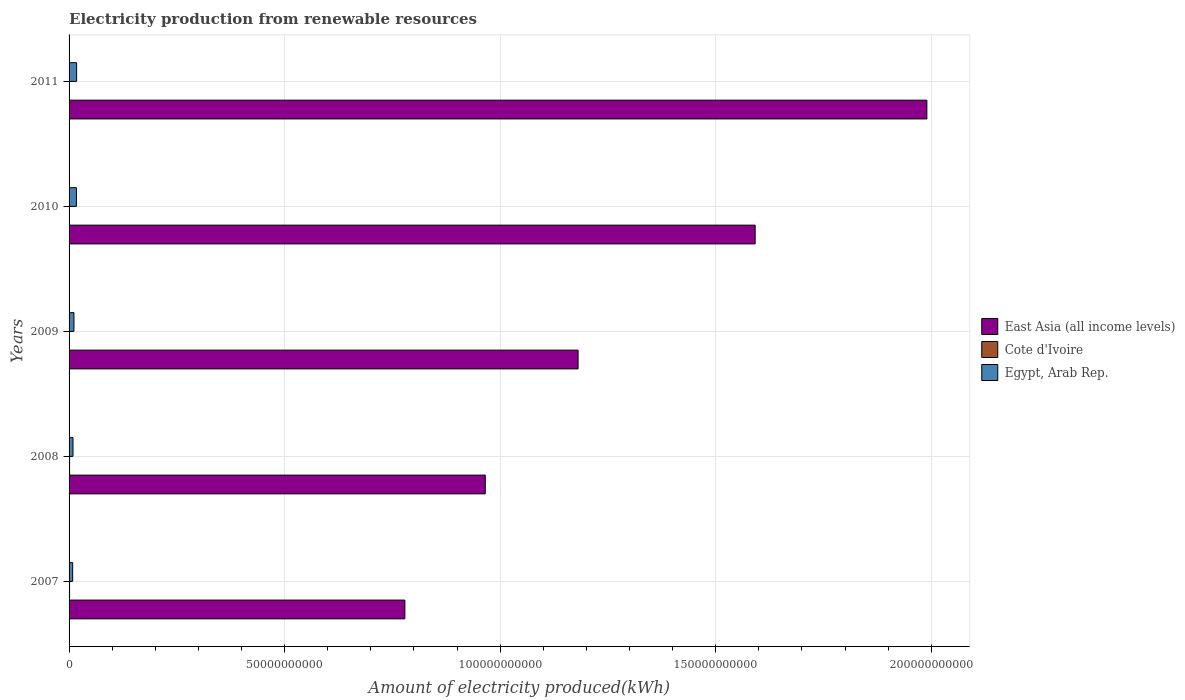How many different coloured bars are there?
Your answer should be very brief. 3. Are the number of bars on each tick of the Y-axis equal?
Provide a succinct answer. Yes. How many bars are there on the 3rd tick from the top?
Make the answer very short. 3. How many bars are there on the 3rd tick from the bottom?
Provide a short and direct response. 3. In how many cases, is the number of bars for a given year not equal to the number of legend labels?
Your answer should be very brief. 0. What is the amount of electricity produced in Cote d'Ivoire in 2008?
Offer a terse response. 1.18e+08. Across all years, what is the maximum amount of electricity produced in East Asia (all income levels)?
Offer a very short reply. 1.99e+11. Across all years, what is the minimum amount of electricity produced in Egypt, Arab Rep.?
Keep it short and to the point. 8.31e+08. In which year was the amount of electricity produced in Egypt, Arab Rep. maximum?
Offer a very short reply. 2011. In which year was the amount of electricity produced in East Asia (all income levels) minimum?
Provide a succinct answer. 2007. What is the total amount of electricity produced in East Asia (all income levels) in the graph?
Offer a terse response. 6.51e+11. What is the difference between the amount of electricity produced in Egypt, Arab Rep. in 2010 and the amount of electricity produced in East Asia (all income levels) in 2011?
Provide a succinct answer. -1.97e+11. What is the average amount of electricity produced in Egypt, Arab Rep. per year?
Give a very brief answer. 1.27e+09. In the year 2011, what is the difference between the amount of electricity produced in Cote d'Ivoire and amount of electricity produced in East Asia (all income levels)?
Your answer should be very brief. -1.99e+11. What is the ratio of the amount of electricity produced in Egypt, Arab Rep. in 2010 to that in 2011?
Ensure brevity in your answer.  0.98. Is the amount of electricity produced in East Asia (all income levels) in 2008 less than that in 2009?
Offer a terse response. Yes. Is the difference between the amount of electricity produced in Cote d'Ivoire in 2007 and 2011 greater than the difference between the amount of electricity produced in East Asia (all income levels) in 2007 and 2011?
Your answer should be very brief. Yes. What is the difference between the highest and the second highest amount of electricity produced in East Asia (all income levels)?
Offer a very short reply. 3.98e+1. What is the difference between the highest and the lowest amount of electricity produced in East Asia (all income levels)?
Make the answer very short. 1.21e+11. Is the sum of the amount of electricity produced in Egypt, Arab Rep. in 2008 and 2009 greater than the maximum amount of electricity produced in East Asia (all income levels) across all years?
Your response must be concise. No. What does the 3rd bar from the top in 2011 represents?
Make the answer very short. East Asia (all income levels). What does the 1st bar from the bottom in 2008 represents?
Your response must be concise. East Asia (all income levels). How many bars are there?
Your response must be concise. 15. How many years are there in the graph?
Provide a short and direct response. 5. Are the values on the major ticks of X-axis written in scientific E-notation?
Offer a terse response. No. Does the graph contain any zero values?
Your answer should be very brief. No. Does the graph contain grids?
Provide a short and direct response. Yes. Where does the legend appear in the graph?
Keep it short and to the point. Center right. What is the title of the graph?
Provide a succinct answer. Electricity production from renewable resources. What is the label or title of the X-axis?
Your answer should be very brief. Amount of electricity produced(kWh). What is the Amount of electricity produced(kWh) of East Asia (all income levels) in 2007?
Keep it short and to the point. 7.79e+1. What is the Amount of electricity produced(kWh) of Cote d'Ivoire in 2007?
Your answer should be compact. 1.15e+08. What is the Amount of electricity produced(kWh) in Egypt, Arab Rep. in 2007?
Ensure brevity in your answer.  8.31e+08. What is the Amount of electricity produced(kWh) in East Asia (all income levels) in 2008?
Your response must be concise. 9.65e+1. What is the Amount of electricity produced(kWh) in Cote d'Ivoire in 2008?
Provide a short and direct response. 1.18e+08. What is the Amount of electricity produced(kWh) of Egypt, Arab Rep. in 2008?
Offer a very short reply. 9.13e+08. What is the Amount of electricity produced(kWh) of East Asia (all income levels) in 2009?
Your response must be concise. 1.18e+11. What is the Amount of electricity produced(kWh) in Cote d'Ivoire in 2009?
Make the answer very short. 7.20e+07. What is the Amount of electricity produced(kWh) in Egypt, Arab Rep. in 2009?
Provide a succinct answer. 1.13e+09. What is the Amount of electricity produced(kWh) in East Asia (all income levels) in 2010?
Your response must be concise. 1.59e+11. What is the Amount of electricity produced(kWh) in Cote d'Ivoire in 2010?
Offer a very short reply. 6.90e+07. What is the Amount of electricity produced(kWh) in Egypt, Arab Rep. in 2010?
Offer a very short reply. 1.70e+09. What is the Amount of electricity produced(kWh) in East Asia (all income levels) in 2011?
Your answer should be compact. 1.99e+11. What is the Amount of electricity produced(kWh) of Cote d'Ivoire in 2011?
Offer a terse response. 6.40e+07. What is the Amount of electricity produced(kWh) of Egypt, Arab Rep. in 2011?
Give a very brief answer. 1.75e+09. Across all years, what is the maximum Amount of electricity produced(kWh) in East Asia (all income levels)?
Offer a very short reply. 1.99e+11. Across all years, what is the maximum Amount of electricity produced(kWh) of Cote d'Ivoire?
Offer a very short reply. 1.18e+08. Across all years, what is the maximum Amount of electricity produced(kWh) in Egypt, Arab Rep.?
Your answer should be very brief. 1.75e+09. Across all years, what is the minimum Amount of electricity produced(kWh) in East Asia (all income levels)?
Your answer should be compact. 7.79e+1. Across all years, what is the minimum Amount of electricity produced(kWh) of Cote d'Ivoire?
Offer a terse response. 6.40e+07. Across all years, what is the minimum Amount of electricity produced(kWh) in Egypt, Arab Rep.?
Your response must be concise. 8.31e+08. What is the total Amount of electricity produced(kWh) in East Asia (all income levels) in the graph?
Ensure brevity in your answer.  6.51e+11. What is the total Amount of electricity produced(kWh) in Cote d'Ivoire in the graph?
Your answer should be compact. 4.38e+08. What is the total Amount of electricity produced(kWh) in Egypt, Arab Rep. in the graph?
Provide a succinct answer. 6.33e+09. What is the difference between the Amount of electricity produced(kWh) in East Asia (all income levels) in 2007 and that in 2008?
Provide a short and direct response. -1.87e+1. What is the difference between the Amount of electricity produced(kWh) of Egypt, Arab Rep. in 2007 and that in 2008?
Ensure brevity in your answer.  -8.20e+07. What is the difference between the Amount of electricity produced(kWh) in East Asia (all income levels) in 2007 and that in 2009?
Offer a very short reply. -4.02e+1. What is the difference between the Amount of electricity produced(kWh) of Cote d'Ivoire in 2007 and that in 2009?
Keep it short and to the point. 4.30e+07. What is the difference between the Amount of electricity produced(kWh) of Egypt, Arab Rep. in 2007 and that in 2009?
Make the answer very short. -3.02e+08. What is the difference between the Amount of electricity produced(kWh) of East Asia (all income levels) in 2007 and that in 2010?
Your response must be concise. -8.13e+1. What is the difference between the Amount of electricity produced(kWh) of Cote d'Ivoire in 2007 and that in 2010?
Provide a short and direct response. 4.60e+07. What is the difference between the Amount of electricity produced(kWh) in Egypt, Arab Rep. in 2007 and that in 2010?
Make the answer very short. -8.73e+08. What is the difference between the Amount of electricity produced(kWh) of East Asia (all income levels) in 2007 and that in 2011?
Make the answer very short. -1.21e+11. What is the difference between the Amount of electricity produced(kWh) of Cote d'Ivoire in 2007 and that in 2011?
Provide a short and direct response. 5.10e+07. What is the difference between the Amount of electricity produced(kWh) of Egypt, Arab Rep. in 2007 and that in 2011?
Ensure brevity in your answer.  -9.16e+08. What is the difference between the Amount of electricity produced(kWh) of East Asia (all income levels) in 2008 and that in 2009?
Provide a short and direct response. -2.15e+1. What is the difference between the Amount of electricity produced(kWh) in Cote d'Ivoire in 2008 and that in 2009?
Give a very brief answer. 4.60e+07. What is the difference between the Amount of electricity produced(kWh) of Egypt, Arab Rep. in 2008 and that in 2009?
Your answer should be compact. -2.20e+08. What is the difference between the Amount of electricity produced(kWh) of East Asia (all income levels) in 2008 and that in 2010?
Keep it short and to the point. -6.26e+1. What is the difference between the Amount of electricity produced(kWh) of Cote d'Ivoire in 2008 and that in 2010?
Ensure brevity in your answer.  4.90e+07. What is the difference between the Amount of electricity produced(kWh) in Egypt, Arab Rep. in 2008 and that in 2010?
Provide a succinct answer. -7.91e+08. What is the difference between the Amount of electricity produced(kWh) in East Asia (all income levels) in 2008 and that in 2011?
Your answer should be very brief. -1.02e+11. What is the difference between the Amount of electricity produced(kWh) in Cote d'Ivoire in 2008 and that in 2011?
Your answer should be compact. 5.40e+07. What is the difference between the Amount of electricity produced(kWh) in Egypt, Arab Rep. in 2008 and that in 2011?
Offer a terse response. -8.34e+08. What is the difference between the Amount of electricity produced(kWh) in East Asia (all income levels) in 2009 and that in 2010?
Your answer should be very brief. -4.11e+1. What is the difference between the Amount of electricity produced(kWh) of Egypt, Arab Rep. in 2009 and that in 2010?
Offer a very short reply. -5.71e+08. What is the difference between the Amount of electricity produced(kWh) of East Asia (all income levels) in 2009 and that in 2011?
Ensure brevity in your answer.  -8.09e+1. What is the difference between the Amount of electricity produced(kWh) in Egypt, Arab Rep. in 2009 and that in 2011?
Provide a succinct answer. -6.14e+08. What is the difference between the Amount of electricity produced(kWh) in East Asia (all income levels) in 2010 and that in 2011?
Offer a terse response. -3.98e+1. What is the difference between the Amount of electricity produced(kWh) of Egypt, Arab Rep. in 2010 and that in 2011?
Ensure brevity in your answer.  -4.30e+07. What is the difference between the Amount of electricity produced(kWh) in East Asia (all income levels) in 2007 and the Amount of electricity produced(kWh) in Cote d'Ivoire in 2008?
Ensure brevity in your answer.  7.78e+1. What is the difference between the Amount of electricity produced(kWh) of East Asia (all income levels) in 2007 and the Amount of electricity produced(kWh) of Egypt, Arab Rep. in 2008?
Your answer should be very brief. 7.70e+1. What is the difference between the Amount of electricity produced(kWh) in Cote d'Ivoire in 2007 and the Amount of electricity produced(kWh) in Egypt, Arab Rep. in 2008?
Provide a succinct answer. -7.98e+08. What is the difference between the Amount of electricity produced(kWh) of East Asia (all income levels) in 2007 and the Amount of electricity produced(kWh) of Cote d'Ivoire in 2009?
Provide a short and direct response. 7.78e+1. What is the difference between the Amount of electricity produced(kWh) in East Asia (all income levels) in 2007 and the Amount of electricity produced(kWh) in Egypt, Arab Rep. in 2009?
Offer a terse response. 7.68e+1. What is the difference between the Amount of electricity produced(kWh) in Cote d'Ivoire in 2007 and the Amount of electricity produced(kWh) in Egypt, Arab Rep. in 2009?
Your answer should be compact. -1.02e+09. What is the difference between the Amount of electricity produced(kWh) of East Asia (all income levels) in 2007 and the Amount of electricity produced(kWh) of Cote d'Ivoire in 2010?
Ensure brevity in your answer.  7.78e+1. What is the difference between the Amount of electricity produced(kWh) of East Asia (all income levels) in 2007 and the Amount of electricity produced(kWh) of Egypt, Arab Rep. in 2010?
Your answer should be very brief. 7.62e+1. What is the difference between the Amount of electricity produced(kWh) in Cote d'Ivoire in 2007 and the Amount of electricity produced(kWh) in Egypt, Arab Rep. in 2010?
Offer a terse response. -1.59e+09. What is the difference between the Amount of electricity produced(kWh) in East Asia (all income levels) in 2007 and the Amount of electricity produced(kWh) in Cote d'Ivoire in 2011?
Provide a succinct answer. 7.78e+1. What is the difference between the Amount of electricity produced(kWh) of East Asia (all income levels) in 2007 and the Amount of electricity produced(kWh) of Egypt, Arab Rep. in 2011?
Your answer should be very brief. 7.61e+1. What is the difference between the Amount of electricity produced(kWh) of Cote d'Ivoire in 2007 and the Amount of electricity produced(kWh) of Egypt, Arab Rep. in 2011?
Provide a succinct answer. -1.63e+09. What is the difference between the Amount of electricity produced(kWh) of East Asia (all income levels) in 2008 and the Amount of electricity produced(kWh) of Cote d'Ivoire in 2009?
Your response must be concise. 9.65e+1. What is the difference between the Amount of electricity produced(kWh) of East Asia (all income levels) in 2008 and the Amount of electricity produced(kWh) of Egypt, Arab Rep. in 2009?
Your answer should be very brief. 9.54e+1. What is the difference between the Amount of electricity produced(kWh) of Cote d'Ivoire in 2008 and the Amount of electricity produced(kWh) of Egypt, Arab Rep. in 2009?
Provide a short and direct response. -1.02e+09. What is the difference between the Amount of electricity produced(kWh) in East Asia (all income levels) in 2008 and the Amount of electricity produced(kWh) in Cote d'Ivoire in 2010?
Offer a very short reply. 9.65e+1. What is the difference between the Amount of electricity produced(kWh) of East Asia (all income levels) in 2008 and the Amount of electricity produced(kWh) of Egypt, Arab Rep. in 2010?
Keep it short and to the point. 9.48e+1. What is the difference between the Amount of electricity produced(kWh) of Cote d'Ivoire in 2008 and the Amount of electricity produced(kWh) of Egypt, Arab Rep. in 2010?
Your response must be concise. -1.59e+09. What is the difference between the Amount of electricity produced(kWh) in East Asia (all income levels) in 2008 and the Amount of electricity produced(kWh) in Cote d'Ivoire in 2011?
Keep it short and to the point. 9.65e+1. What is the difference between the Amount of electricity produced(kWh) of East Asia (all income levels) in 2008 and the Amount of electricity produced(kWh) of Egypt, Arab Rep. in 2011?
Your answer should be compact. 9.48e+1. What is the difference between the Amount of electricity produced(kWh) of Cote d'Ivoire in 2008 and the Amount of electricity produced(kWh) of Egypt, Arab Rep. in 2011?
Ensure brevity in your answer.  -1.63e+09. What is the difference between the Amount of electricity produced(kWh) of East Asia (all income levels) in 2009 and the Amount of electricity produced(kWh) of Cote d'Ivoire in 2010?
Keep it short and to the point. 1.18e+11. What is the difference between the Amount of electricity produced(kWh) in East Asia (all income levels) in 2009 and the Amount of electricity produced(kWh) in Egypt, Arab Rep. in 2010?
Make the answer very short. 1.16e+11. What is the difference between the Amount of electricity produced(kWh) in Cote d'Ivoire in 2009 and the Amount of electricity produced(kWh) in Egypt, Arab Rep. in 2010?
Your answer should be compact. -1.63e+09. What is the difference between the Amount of electricity produced(kWh) in East Asia (all income levels) in 2009 and the Amount of electricity produced(kWh) in Cote d'Ivoire in 2011?
Provide a succinct answer. 1.18e+11. What is the difference between the Amount of electricity produced(kWh) in East Asia (all income levels) in 2009 and the Amount of electricity produced(kWh) in Egypt, Arab Rep. in 2011?
Offer a terse response. 1.16e+11. What is the difference between the Amount of electricity produced(kWh) of Cote d'Ivoire in 2009 and the Amount of electricity produced(kWh) of Egypt, Arab Rep. in 2011?
Offer a terse response. -1.68e+09. What is the difference between the Amount of electricity produced(kWh) of East Asia (all income levels) in 2010 and the Amount of electricity produced(kWh) of Cote d'Ivoire in 2011?
Make the answer very short. 1.59e+11. What is the difference between the Amount of electricity produced(kWh) in East Asia (all income levels) in 2010 and the Amount of electricity produced(kWh) in Egypt, Arab Rep. in 2011?
Make the answer very short. 1.57e+11. What is the difference between the Amount of electricity produced(kWh) of Cote d'Ivoire in 2010 and the Amount of electricity produced(kWh) of Egypt, Arab Rep. in 2011?
Give a very brief answer. -1.68e+09. What is the average Amount of electricity produced(kWh) of East Asia (all income levels) per year?
Offer a very short reply. 1.30e+11. What is the average Amount of electricity produced(kWh) in Cote d'Ivoire per year?
Provide a short and direct response. 8.76e+07. What is the average Amount of electricity produced(kWh) of Egypt, Arab Rep. per year?
Your answer should be compact. 1.27e+09. In the year 2007, what is the difference between the Amount of electricity produced(kWh) of East Asia (all income levels) and Amount of electricity produced(kWh) of Cote d'Ivoire?
Provide a succinct answer. 7.78e+1. In the year 2007, what is the difference between the Amount of electricity produced(kWh) in East Asia (all income levels) and Amount of electricity produced(kWh) in Egypt, Arab Rep.?
Your response must be concise. 7.71e+1. In the year 2007, what is the difference between the Amount of electricity produced(kWh) of Cote d'Ivoire and Amount of electricity produced(kWh) of Egypt, Arab Rep.?
Make the answer very short. -7.16e+08. In the year 2008, what is the difference between the Amount of electricity produced(kWh) in East Asia (all income levels) and Amount of electricity produced(kWh) in Cote d'Ivoire?
Provide a succinct answer. 9.64e+1. In the year 2008, what is the difference between the Amount of electricity produced(kWh) of East Asia (all income levels) and Amount of electricity produced(kWh) of Egypt, Arab Rep.?
Make the answer very short. 9.56e+1. In the year 2008, what is the difference between the Amount of electricity produced(kWh) in Cote d'Ivoire and Amount of electricity produced(kWh) in Egypt, Arab Rep.?
Your answer should be very brief. -7.95e+08. In the year 2009, what is the difference between the Amount of electricity produced(kWh) of East Asia (all income levels) and Amount of electricity produced(kWh) of Cote d'Ivoire?
Give a very brief answer. 1.18e+11. In the year 2009, what is the difference between the Amount of electricity produced(kWh) of East Asia (all income levels) and Amount of electricity produced(kWh) of Egypt, Arab Rep.?
Offer a very short reply. 1.17e+11. In the year 2009, what is the difference between the Amount of electricity produced(kWh) of Cote d'Ivoire and Amount of electricity produced(kWh) of Egypt, Arab Rep.?
Your answer should be compact. -1.06e+09. In the year 2010, what is the difference between the Amount of electricity produced(kWh) of East Asia (all income levels) and Amount of electricity produced(kWh) of Cote d'Ivoire?
Give a very brief answer. 1.59e+11. In the year 2010, what is the difference between the Amount of electricity produced(kWh) in East Asia (all income levels) and Amount of electricity produced(kWh) in Egypt, Arab Rep.?
Your answer should be very brief. 1.57e+11. In the year 2010, what is the difference between the Amount of electricity produced(kWh) in Cote d'Ivoire and Amount of electricity produced(kWh) in Egypt, Arab Rep.?
Offer a very short reply. -1.64e+09. In the year 2011, what is the difference between the Amount of electricity produced(kWh) in East Asia (all income levels) and Amount of electricity produced(kWh) in Cote d'Ivoire?
Provide a succinct answer. 1.99e+11. In the year 2011, what is the difference between the Amount of electricity produced(kWh) in East Asia (all income levels) and Amount of electricity produced(kWh) in Egypt, Arab Rep.?
Provide a succinct answer. 1.97e+11. In the year 2011, what is the difference between the Amount of electricity produced(kWh) of Cote d'Ivoire and Amount of electricity produced(kWh) of Egypt, Arab Rep.?
Provide a succinct answer. -1.68e+09. What is the ratio of the Amount of electricity produced(kWh) in East Asia (all income levels) in 2007 to that in 2008?
Provide a short and direct response. 0.81. What is the ratio of the Amount of electricity produced(kWh) in Cote d'Ivoire in 2007 to that in 2008?
Keep it short and to the point. 0.97. What is the ratio of the Amount of electricity produced(kWh) in Egypt, Arab Rep. in 2007 to that in 2008?
Offer a very short reply. 0.91. What is the ratio of the Amount of electricity produced(kWh) in East Asia (all income levels) in 2007 to that in 2009?
Offer a terse response. 0.66. What is the ratio of the Amount of electricity produced(kWh) of Cote d'Ivoire in 2007 to that in 2009?
Your answer should be very brief. 1.6. What is the ratio of the Amount of electricity produced(kWh) in Egypt, Arab Rep. in 2007 to that in 2009?
Offer a very short reply. 0.73. What is the ratio of the Amount of electricity produced(kWh) in East Asia (all income levels) in 2007 to that in 2010?
Provide a succinct answer. 0.49. What is the ratio of the Amount of electricity produced(kWh) in Cote d'Ivoire in 2007 to that in 2010?
Your response must be concise. 1.67. What is the ratio of the Amount of electricity produced(kWh) in Egypt, Arab Rep. in 2007 to that in 2010?
Offer a terse response. 0.49. What is the ratio of the Amount of electricity produced(kWh) in East Asia (all income levels) in 2007 to that in 2011?
Ensure brevity in your answer.  0.39. What is the ratio of the Amount of electricity produced(kWh) of Cote d'Ivoire in 2007 to that in 2011?
Ensure brevity in your answer.  1.8. What is the ratio of the Amount of electricity produced(kWh) of Egypt, Arab Rep. in 2007 to that in 2011?
Make the answer very short. 0.48. What is the ratio of the Amount of electricity produced(kWh) in East Asia (all income levels) in 2008 to that in 2009?
Offer a very short reply. 0.82. What is the ratio of the Amount of electricity produced(kWh) in Cote d'Ivoire in 2008 to that in 2009?
Offer a terse response. 1.64. What is the ratio of the Amount of electricity produced(kWh) in Egypt, Arab Rep. in 2008 to that in 2009?
Give a very brief answer. 0.81. What is the ratio of the Amount of electricity produced(kWh) of East Asia (all income levels) in 2008 to that in 2010?
Your answer should be very brief. 0.61. What is the ratio of the Amount of electricity produced(kWh) of Cote d'Ivoire in 2008 to that in 2010?
Your answer should be very brief. 1.71. What is the ratio of the Amount of electricity produced(kWh) of Egypt, Arab Rep. in 2008 to that in 2010?
Offer a terse response. 0.54. What is the ratio of the Amount of electricity produced(kWh) of East Asia (all income levels) in 2008 to that in 2011?
Give a very brief answer. 0.49. What is the ratio of the Amount of electricity produced(kWh) in Cote d'Ivoire in 2008 to that in 2011?
Your response must be concise. 1.84. What is the ratio of the Amount of electricity produced(kWh) in Egypt, Arab Rep. in 2008 to that in 2011?
Offer a very short reply. 0.52. What is the ratio of the Amount of electricity produced(kWh) in East Asia (all income levels) in 2009 to that in 2010?
Your response must be concise. 0.74. What is the ratio of the Amount of electricity produced(kWh) in Cote d'Ivoire in 2009 to that in 2010?
Provide a succinct answer. 1.04. What is the ratio of the Amount of electricity produced(kWh) of Egypt, Arab Rep. in 2009 to that in 2010?
Your response must be concise. 0.66. What is the ratio of the Amount of electricity produced(kWh) in East Asia (all income levels) in 2009 to that in 2011?
Ensure brevity in your answer.  0.59. What is the ratio of the Amount of electricity produced(kWh) of Egypt, Arab Rep. in 2009 to that in 2011?
Provide a succinct answer. 0.65. What is the ratio of the Amount of electricity produced(kWh) of East Asia (all income levels) in 2010 to that in 2011?
Ensure brevity in your answer.  0.8. What is the ratio of the Amount of electricity produced(kWh) in Cote d'Ivoire in 2010 to that in 2011?
Provide a succinct answer. 1.08. What is the ratio of the Amount of electricity produced(kWh) of Egypt, Arab Rep. in 2010 to that in 2011?
Ensure brevity in your answer.  0.98. What is the difference between the highest and the second highest Amount of electricity produced(kWh) of East Asia (all income levels)?
Give a very brief answer. 3.98e+1. What is the difference between the highest and the second highest Amount of electricity produced(kWh) of Egypt, Arab Rep.?
Ensure brevity in your answer.  4.30e+07. What is the difference between the highest and the lowest Amount of electricity produced(kWh) in East Asia (all income levels)?
Offer a very short reply. 1.21e+11. What is the difference between the highest and the lowest Amount of electricity produced(kWh) in Cote d'Ivoire?
Make the answer very short. 5.40e+07. What is the difference between the highest and the lowest Amount of electricity produced(kWh) in Egypt, Arab Rep.?
Provide a succinct answer. 9.16e+08. 